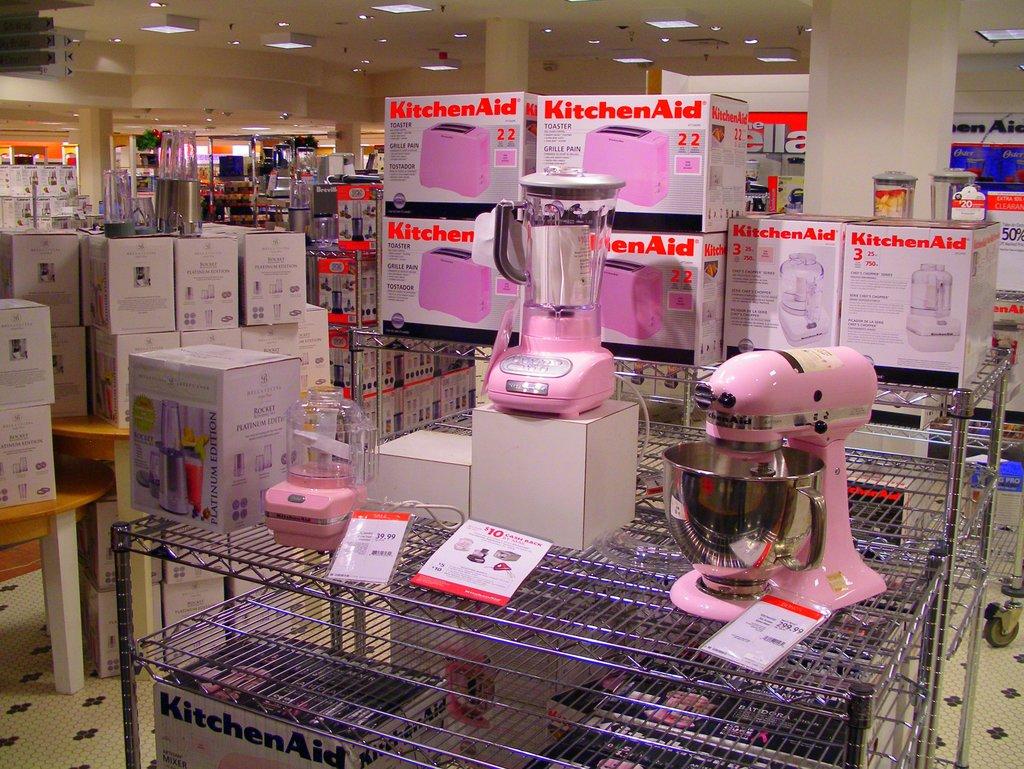What kitchen brand is on the boxes?
Give a very brief answer. Kitchenaid. What types of appliances are in the boxes?
Your answer should be very brief. Toaster, blender. 